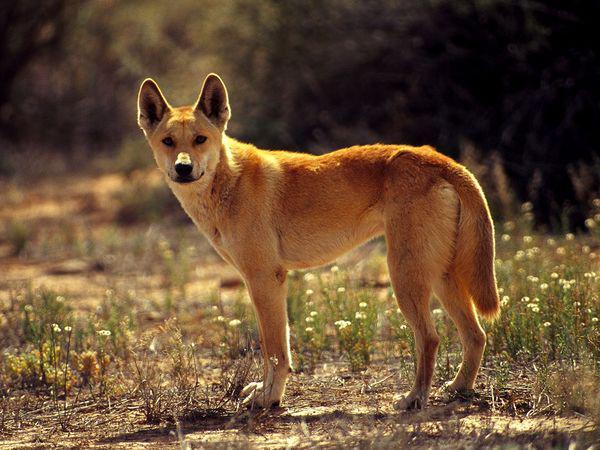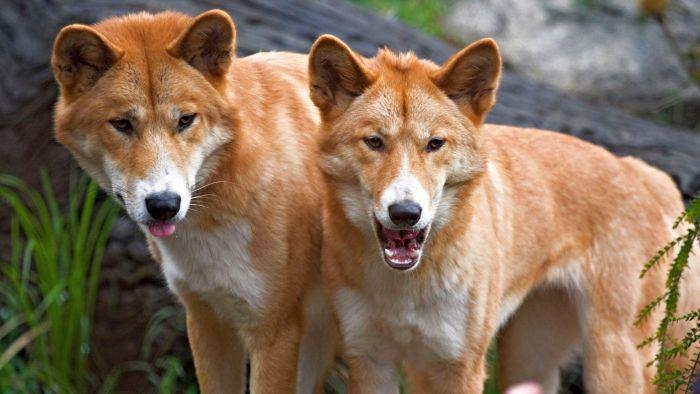The first image is the image on the left, the second image is the image on the right. Assess this claim about the two images: "In the left image, a lone dog stands up, and is looking right at the camera.". Correct or not? Answer yes or no. Yes. 